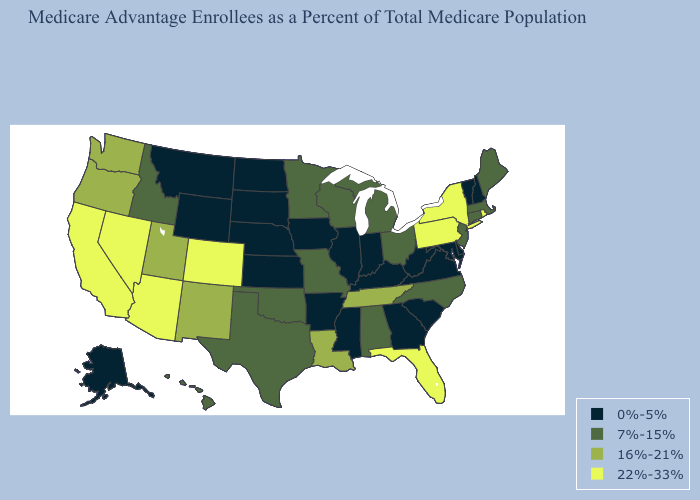Name the states that have a value in the range 16%-21%?
Concise answer only. Louisiana, New Mexico, Oregon, Tennessee, Utah, Washington. What is the highest value in the South ?
Concise answer only. 22%-33%. What is the value of Kansas?
Give a very brief answer. 0%-5%. Which states have the lowest value in the USA?
Keep it brief. Alaska, Arkansas, Delaware, Georgia, Iowa, Illinois, Indiana, Kansas, Kentucky, Maryland, Mississippi, Montana, North Dakota, Nebraska, New Hampshire, South Carolina, South Dakota, Virginia, Vermont, West Virginia, Wyoming. Does Illinois have a lower value than Virginia?
Short answer required. No. Name the states that have a value in the range 16%-21%?
Give a very brief answer. Louisiana, New Mexico, Oregon, Tennessee, Utah, Washington. What is the value of Pennsylvania?
Write a very short answer. 22%-33%. What is the value of Georgia?
Quick response, please. 0%-5%. Which states have the lowest value in the USA?
Give a very brief answer. Alaska, Arkansas, Delaware, Georgia, Iowa, Illinois, Indiana, Kansas, Kentucky, Maryland, Mississippi, Montana, North Dakota, Nebraska, New Hampshire, South Carolina, South Dakota, Virginia, Vermont, West Virginia, Wyoming. Name the states that have a value in the range 16%-21%?
Keep it brief. Louisiana, New Mexico, Oregon, Tennessee, Utah, Washington. Does Virginia have a lower value than New Hampshire?
Write a very short answer. No. Is the legend a continuous bar?
Be succinct. No. Which states have the lowest value in the USA?
Write a very short answer. Alaska, Arkansas, Delaware, Georgia, Iowa, Illinois, Indiana, Kansas, Kentucky, Maryland, Mississippi, Montana, North Dakota, Nebraska, New Hampshire, South Carolina, South Dakota, Virginia, Vermont, West Virginia, Wyoming. What is the highest value in the USA?
Give a very brief answer. 22%-33%. Among the states that border Indiana , does Illinois have the lowest value?
Concise answer only. Yes. 